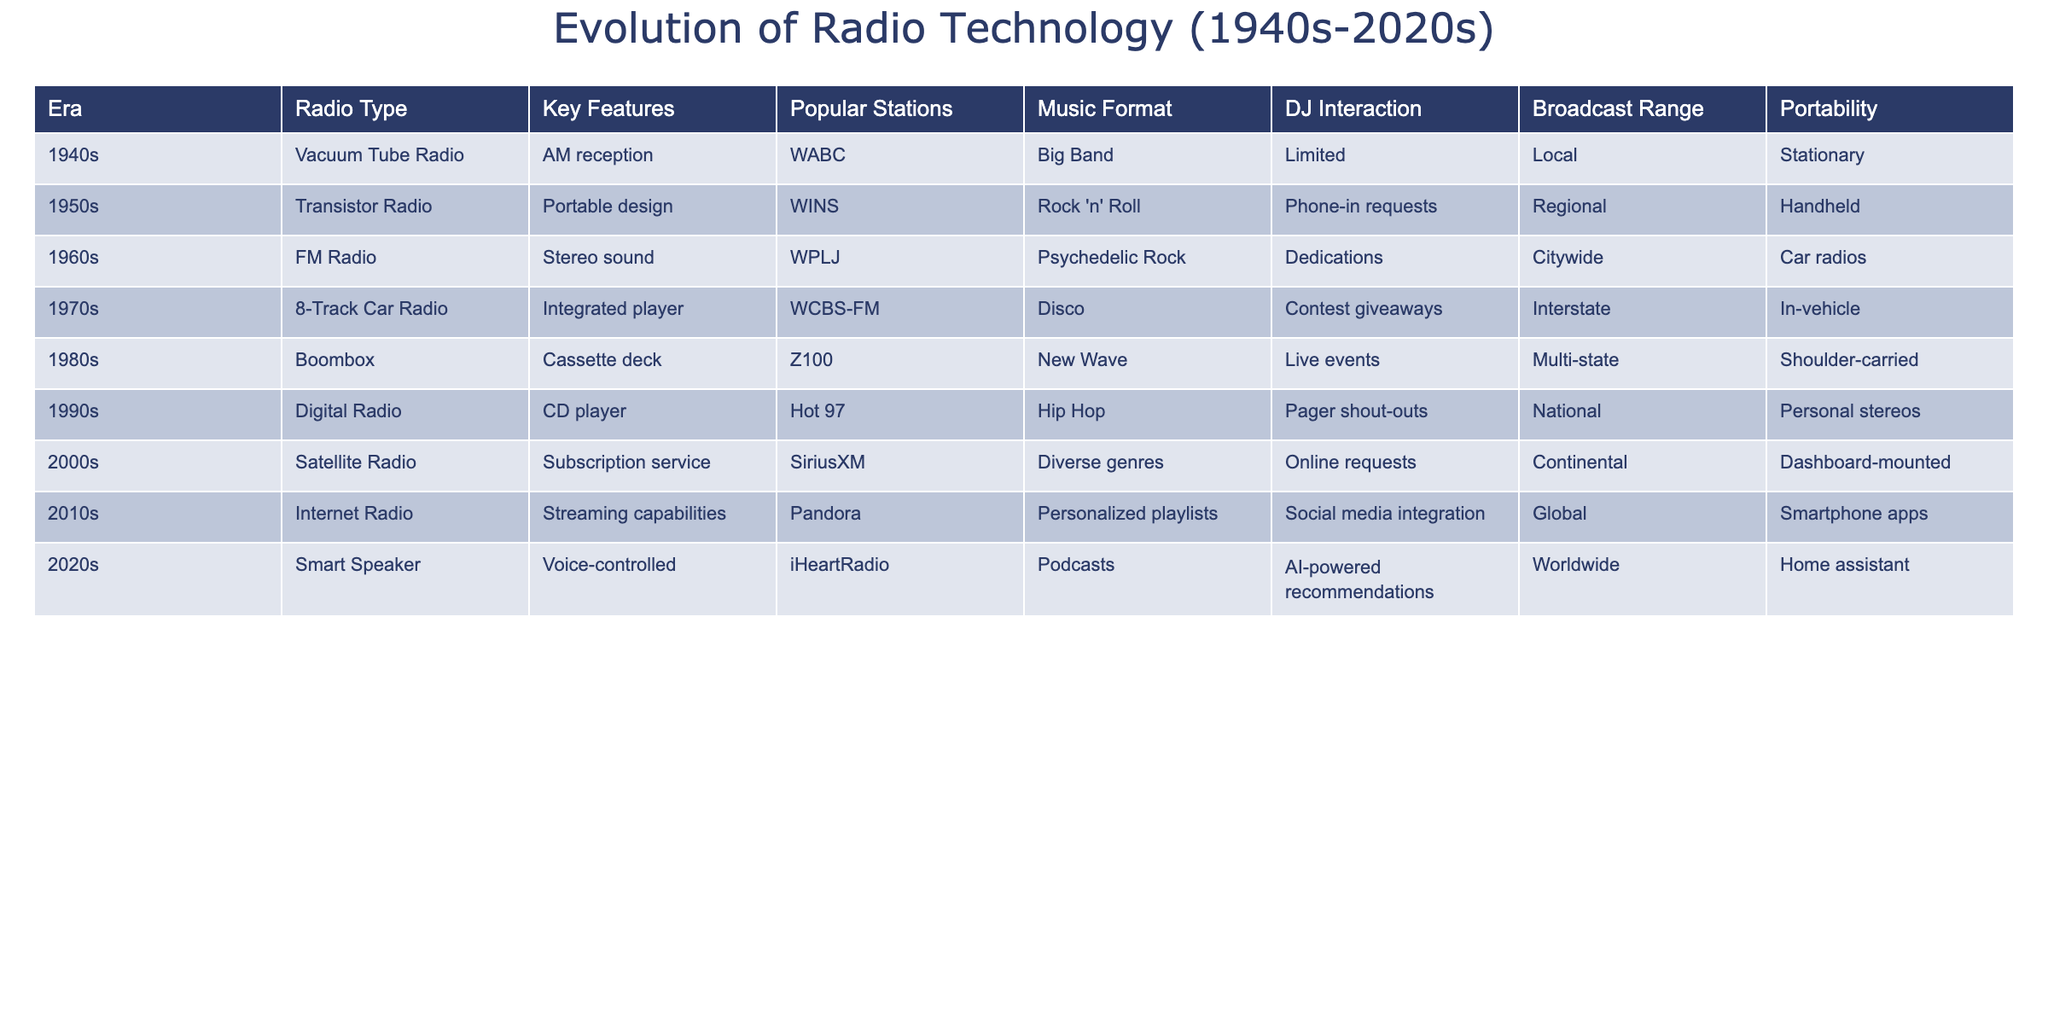What radio type was popular in the 1980s? By looking at the table, we can find the row corresponding to the 1980s, which identifies the radio type as "Boombox."
Answer: Boombox Which music format was most associated with the 1970s? Referring to the entry for the 1970s, the music format listed is "Disco."
Answer: Disco Did the 2000s see the introduction of voice-controlled technology in radios? According to the table, the 2000s introduced "Satellite Radio," which does not mention voice control; instead, that feature appears in the 2020s. Thus, the statement is false.
Answer: No What is the difference in portability between radios from the 1960s and the 2020s? Looking at the table, the 1960s FM Radio is categorized as "Car radios," which indicates it has limited portability outside of vehicles, while the 2020s Smart Speaker is described as a "Home assistant," suggesting it is stationary. Therefore, the difference is notable as the 2020s technology provides different usage contexts.
Answer: 1960s: Car radios, 2020s: Home assistant; Difference notable Which era featured the integration of a cassette deck in radios? We can find that the "Boombox" was the radio type in the 1980s, indicating that this era featured the integration of a cassette deck.
Answer: 1980s How many radio types in the 1990s allowed for some form of user interaction? The table shows that the 1990s Digital Radio facilitated "Pager shout-outs," thus allowing for user interaction, which means there is one such radio type identified in that decade.
Answer: One What was the broadcast range of the radio technology in the 1950s compared to the 2020s? From the table, the 1950s transistor radio had a "Regional" range, while the 2020s Smart Speaker has a "Worldwide" range, indicating that the range has significantly expanded over time.
Answer: Regional vs. Worldwide; significant expansion In which decade did radio technology transition from AM to FM and what were the popular stations? The transition to FM occurred in the 1960s, as noted in the table, with WPLJ being a popular station during that time.
Answer: 1960s, popular station: WPLJ 